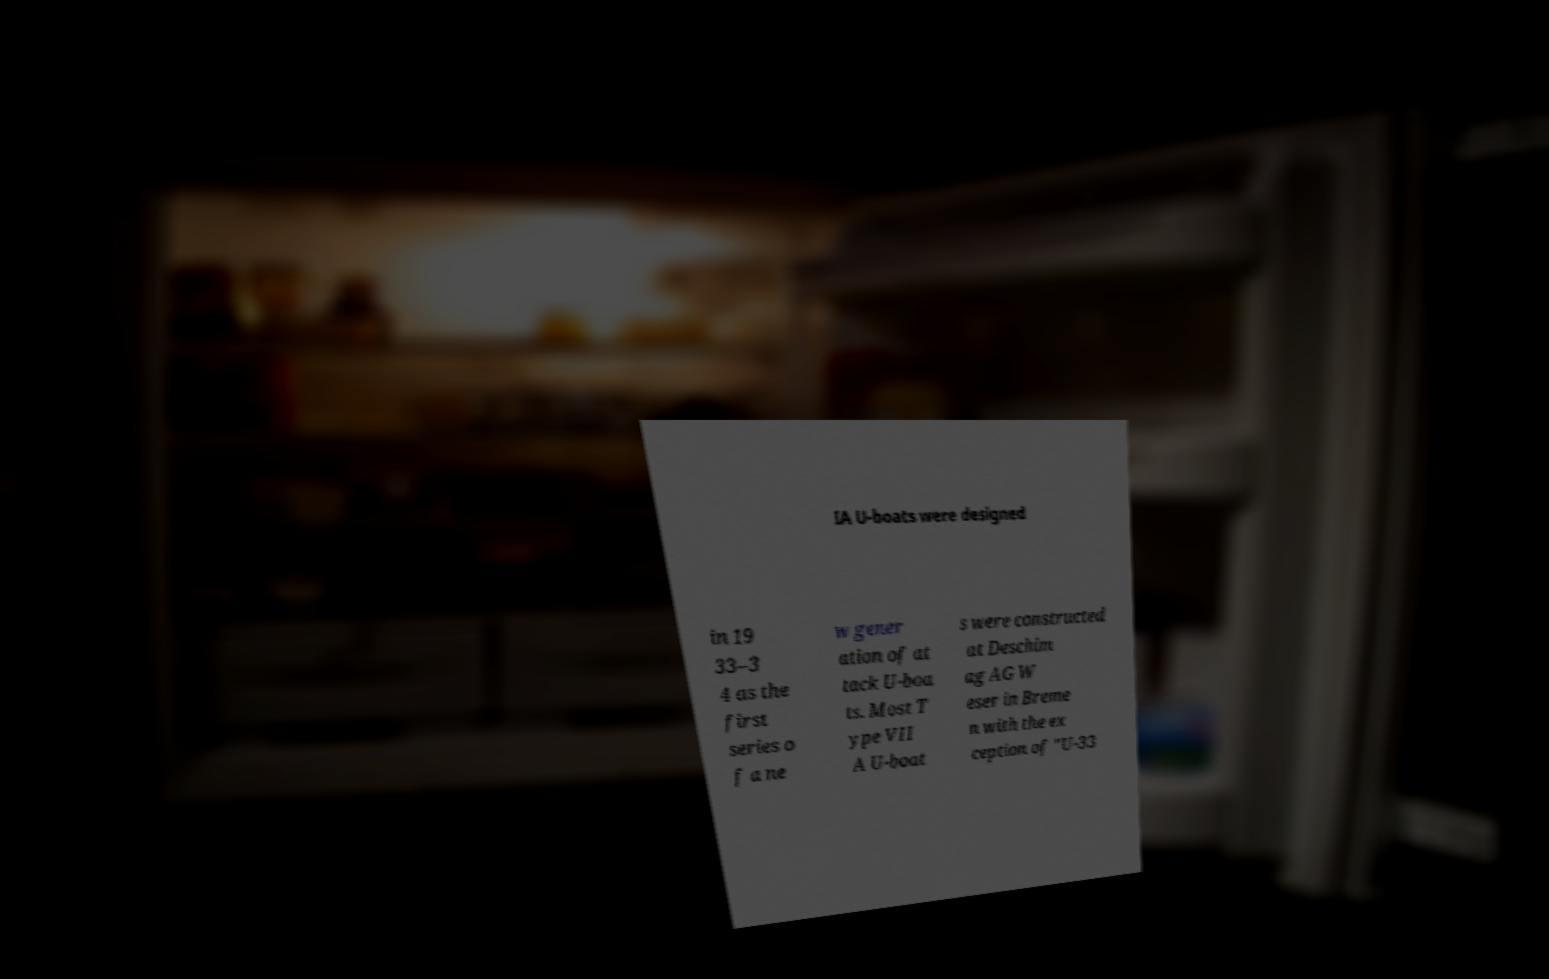What messages or text are displayed in this image? I need them in a readable, typed format. IA U-boats were designed in 19 33–3 4 as the first series o f a ne w gener ation of at tack U-boa ts. Most T ype VII A U-boat s were constructed at Deschim ag AG W eser in Breme n with the ex ception of "U-33 